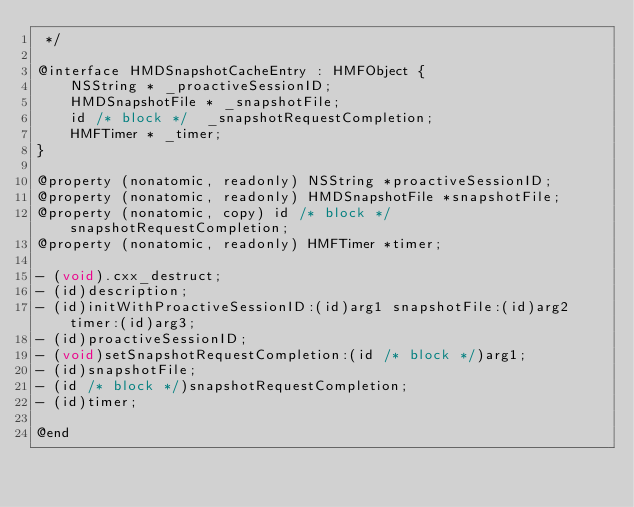<code> <loc_0><loc_0><loc_500><loc_500><_C_> */

@interface HMDSnapshotCacheEntry : HMFObject {
    NSString * _proactiveSessionID;
    HMDSnapshotFile * _snapshotFile;
    id /* block */  _snapshotRequestCompletion;
    HMFTimer * _timer;
}

@property (nonatomic, readonly) NSString *proactiveSessionID;
@property (nonatomic, readonly) HMDSnapshotFile *snapshotFile;
@property (nonatomic, copy) id /* block */ snapshotRequestCompletion;
@property (nonatomic, readonly) HMFTimer *timer;

- (void).cxx_destruct;
- (id)description;
- (id)initWithProactiveSessionID:(id)arg1 snapshotFile:(id)arg2 timer:(id)arg3;
- (id)proactiveSessionID;
- (void)setSnapshotRequestCompletion:(id /* block */)arg1;
- (id)snapshotFile;
- (id /* block */)snapshotRequestCompletion;
- (id)timer;

@end
</code> 